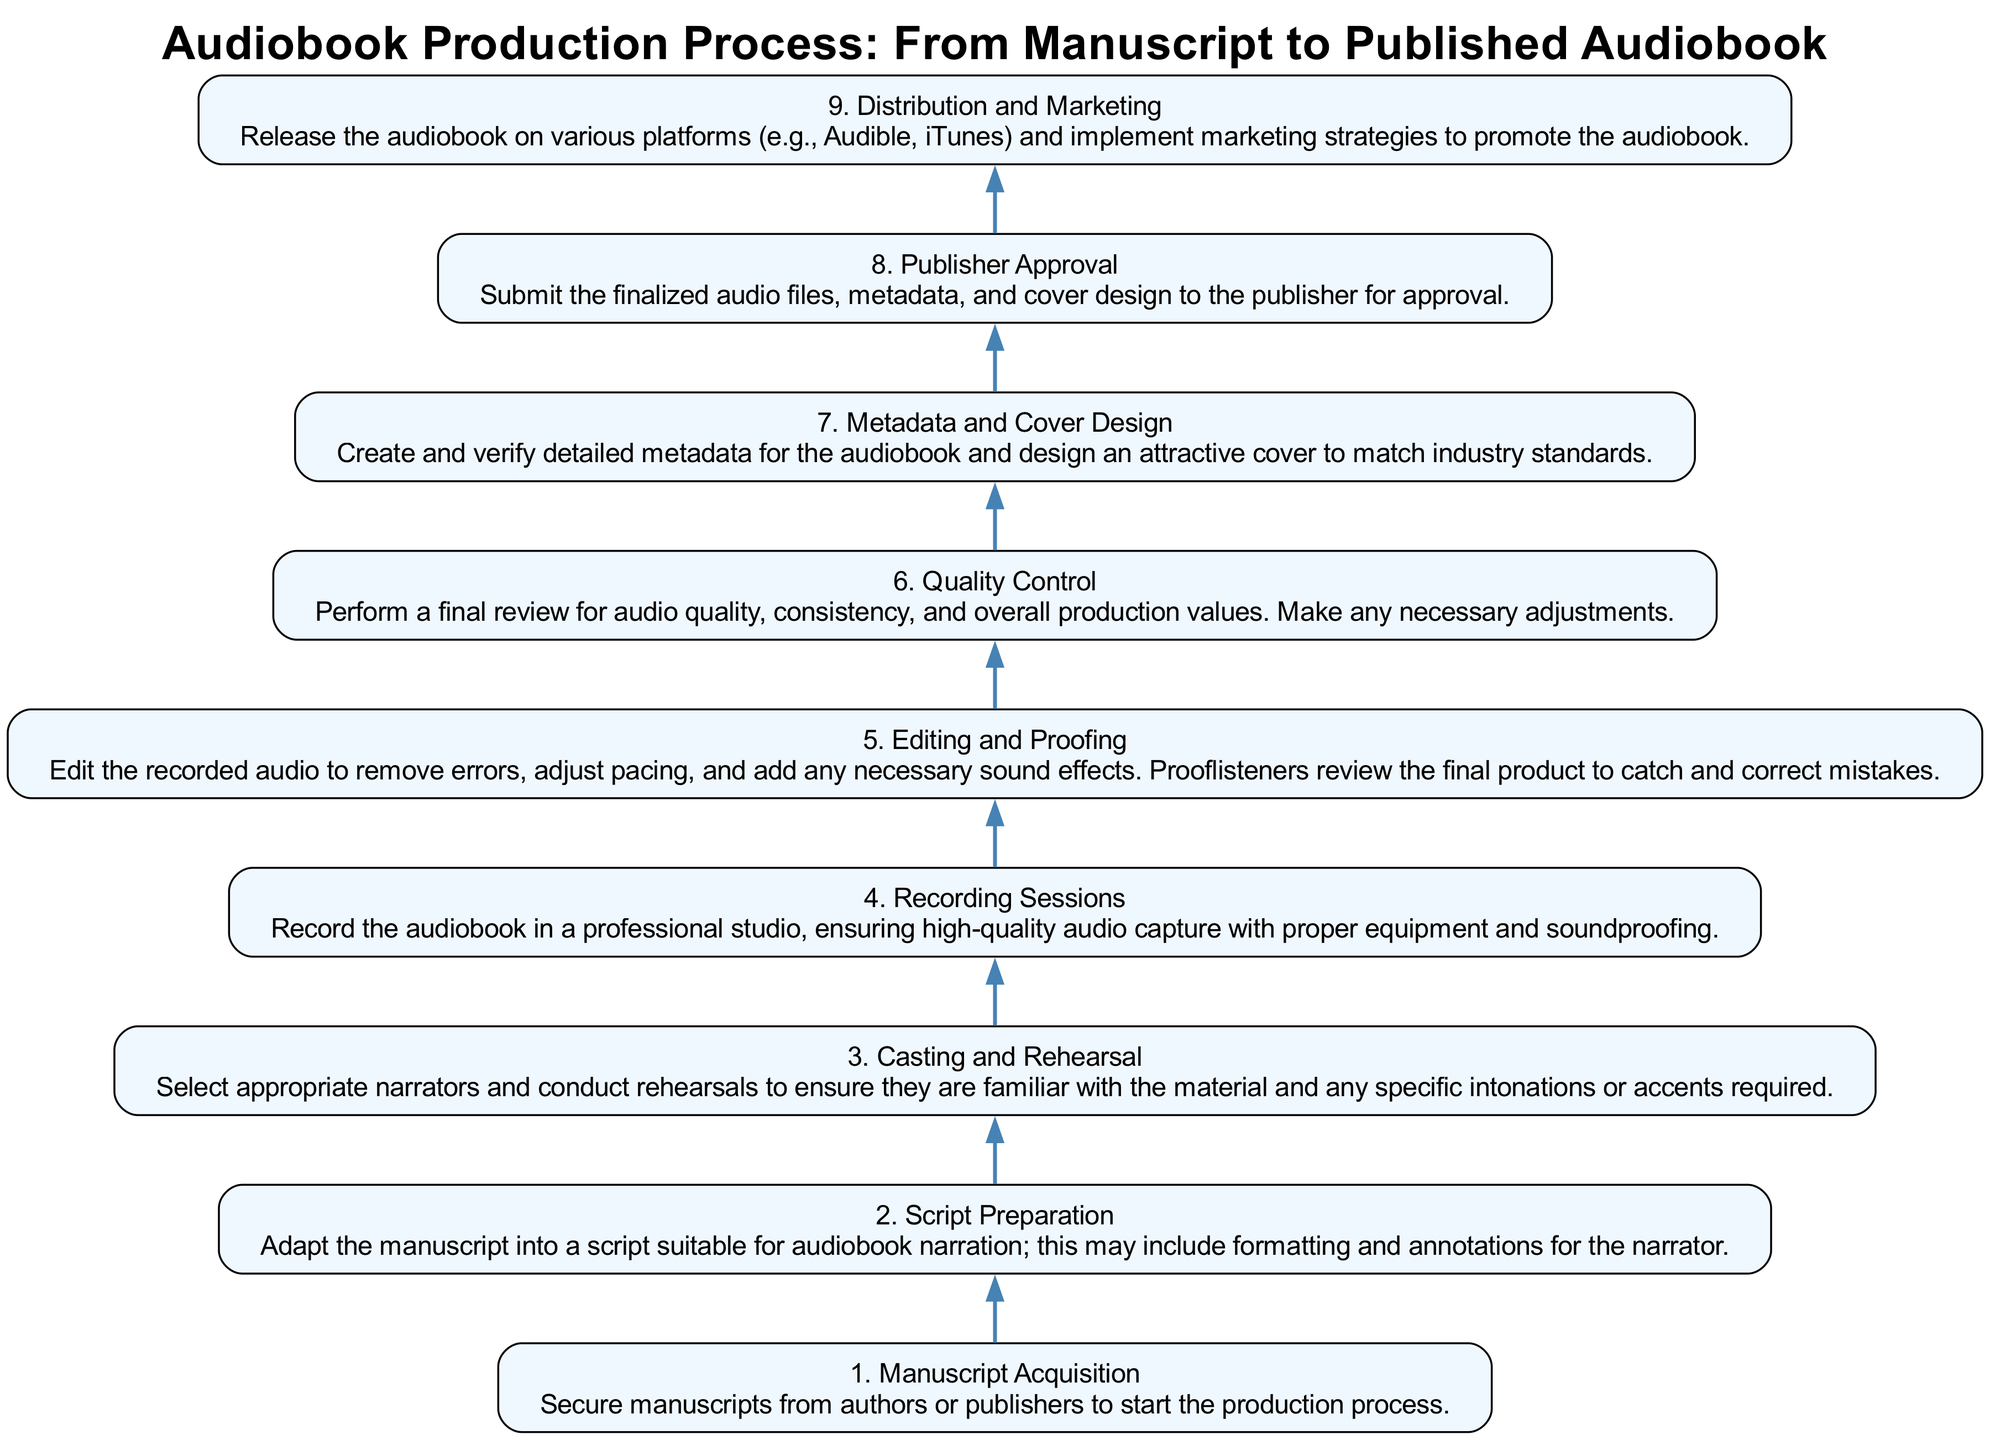What is the first step in the audiobook production process? The diagram indicates the first step is "Manuscript Acquisition," which is the title of the first node in the flow chart.
Answer: Manuscript Acquisition How many steps are there in total in the process? By counting the nodes listed in the diagram, we find there are a total of nine steps in the production process.
Answer: 9 What is the last step before distribution? The last step before distribution is "Publisher Approval," which is the eighth step as shown in the diagram.
Answer: Publisher Approval What is the main activity during the fourth step? The fourth step is labeled "Recording Sessions," which specifies that the main activity involves recording the audiobook in a professional studio.
Answer: Recording Sessions Which step directly follows "Casting and Rehearsal"? According to the flow chart, the step that follows "Casting and Rehearsal" is "Recording Sessions," represented as the fourth step.
Answer: Recording Sessions Explain what happens between the "Editing and Proofing" and "Quality Control" steps. After "Editing and Proofing," where the audio is edited for errors and reviewed by prooflisteners, the next step is "Quality Control," which involves a final review for audio quality and production values.
Answer: Final review for audio quality What two components are created during the "Metadata and Cover Design" step? During the "Metadata and Cover Design" step, detailed metadata for the audiobook and an attractive cover are created as per the description in the diagram.
Answer: Metadata and Cover How does "Script Preparation" relate to "Manuscript Acquisition"? "Script Preparation" follows "Manuscript Acquisition" in the flow, meaning it is the next step after manuscripts have been secured—indicating a direct relationship where one step leads to the next sequentially in the process.
Answer: Next step in the process What is necessary before the audio files can be distributed? Before distribution, the audio files, metadata, and cover design must receive "Publisher Approval," indicating this approval is a prerequisite for distribution.
Answer: Publisher Approval 